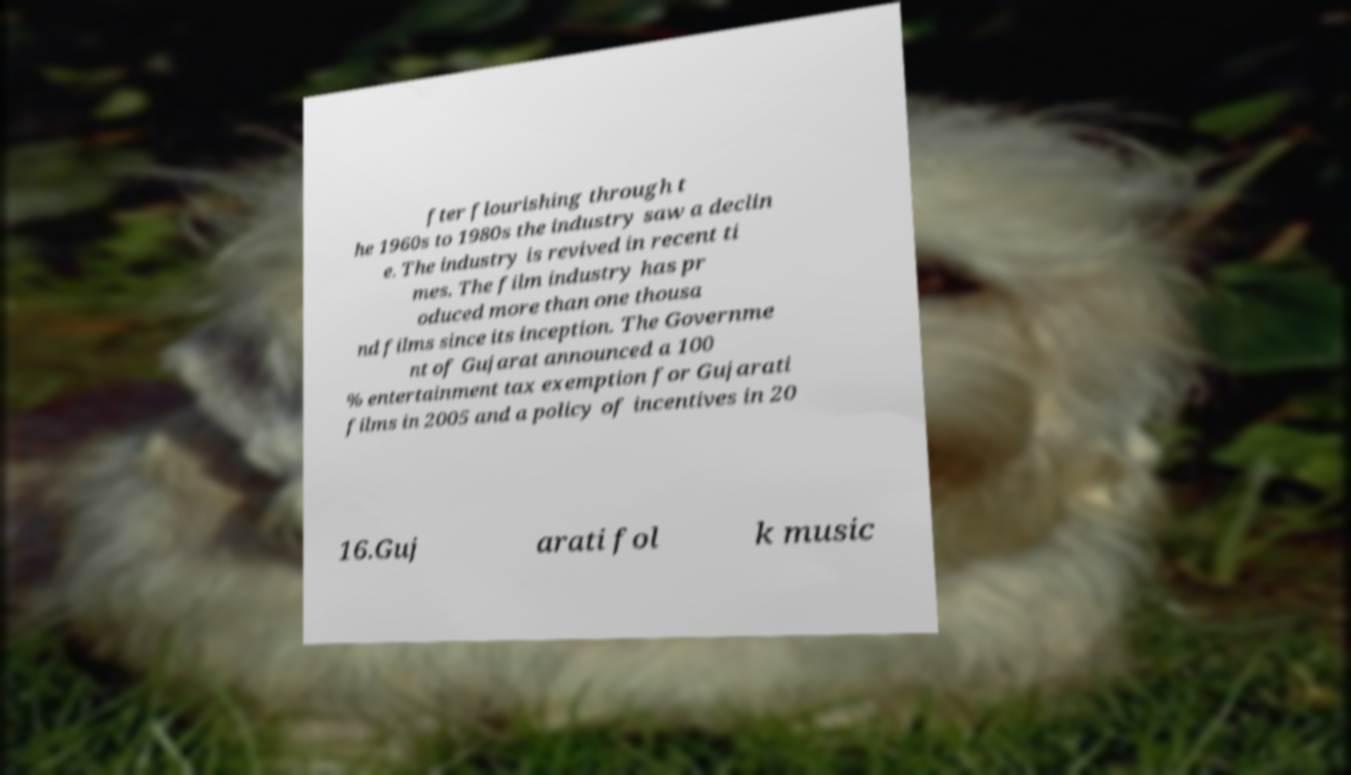Can you accurately transcribe the text from the provided image for me? fter flourishing through t he 1960s to 1980s the industry saw a declin e. The industry is revived in recent ti mes. The film industry has pr oduced more than one thousa nd films since its inception. The Governme nt of Gujarat announced a 100 % entertainment tax exemption for Gujarati films in 2005 and a policy of incentives in 20 16.Guj arati fol k music 